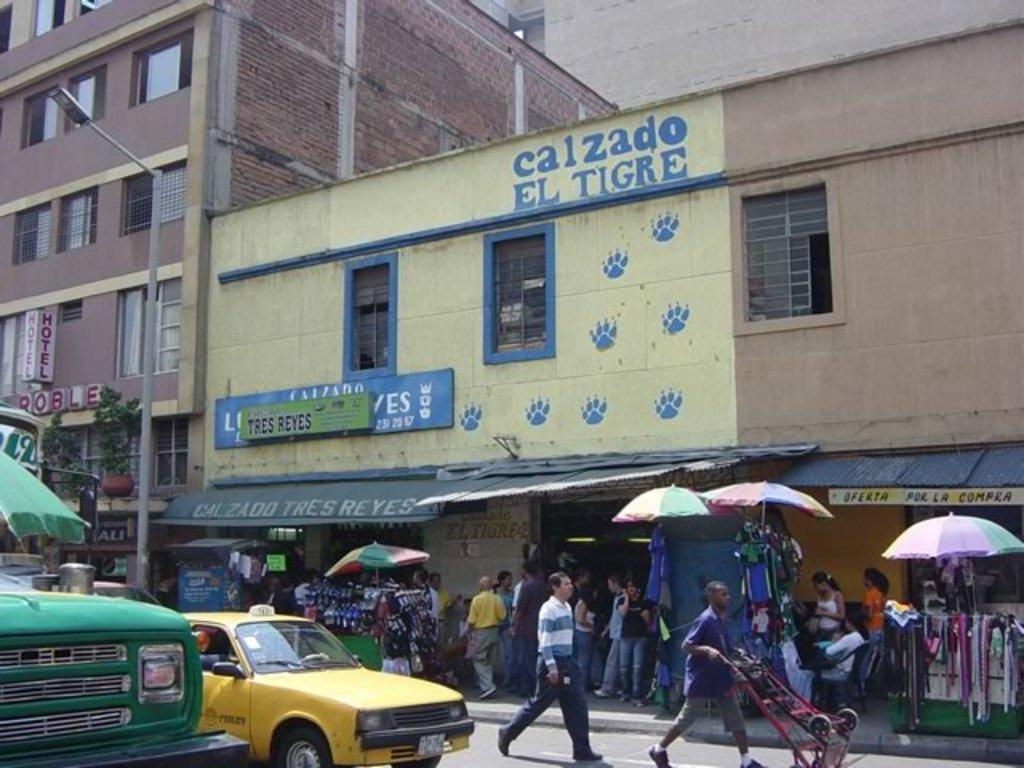<image>
Relay a brief, clear account of the picture shown. A busy city street teems with people in front of a building called Calzado el Tigre. 